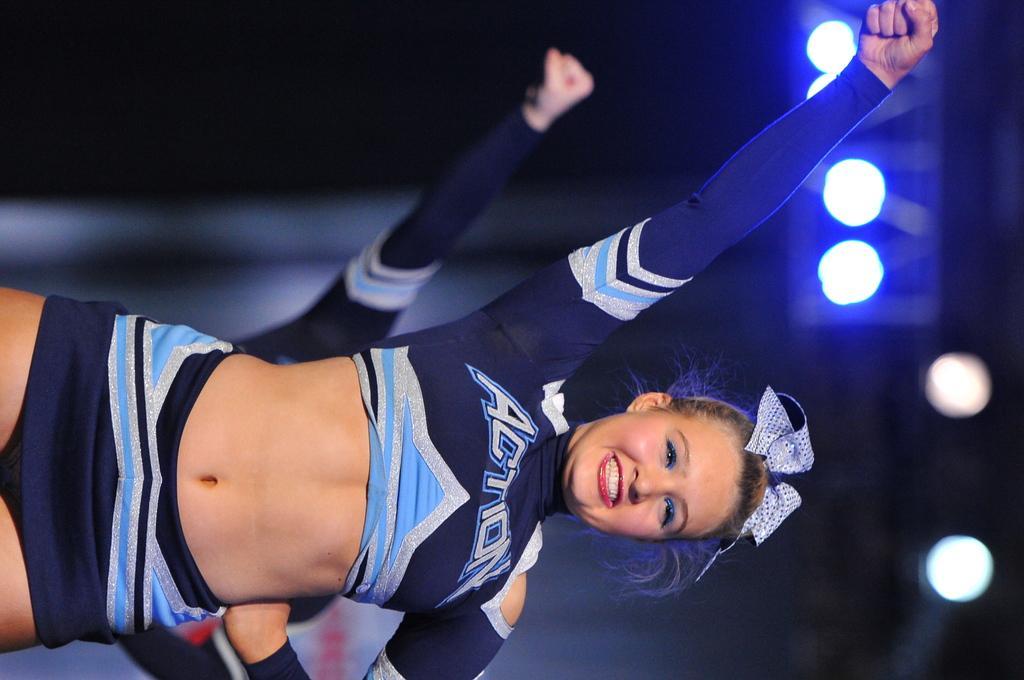Please provide a concise description of this image. In this picture there is a woman standing and smiling. At the back there is a person. At the top there are lights. 